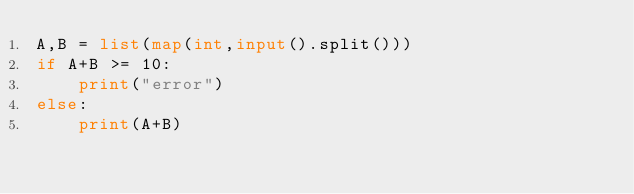<code> <loc_0><loc_0><loc_500><loc_500><_Python_>A,B = list(map(int,input().split()))
if A+B >= 10:
    print("error")
else:
    print(A+B)</code> 